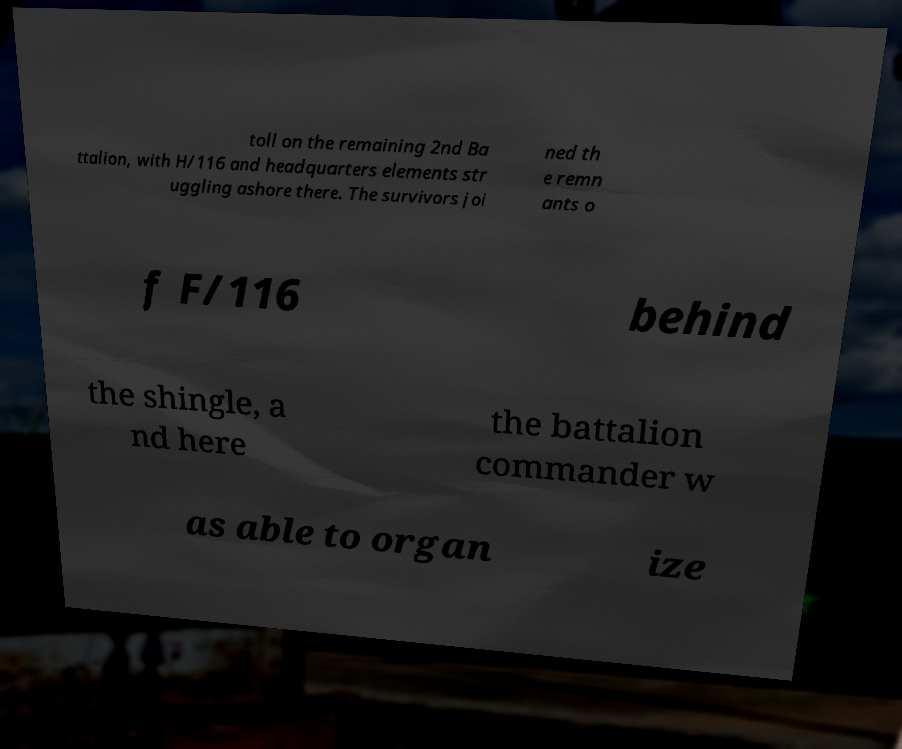Can you accurately transcribe the text from the provided image for me? toll on the remaining 2nd Ba ttalion, with H/116 and headquarters elements str uggling ashore there. The survivors joi ned th e remn ants o f F/116 behind the shingle, a nd here the battalion commander w as able to organ ize 